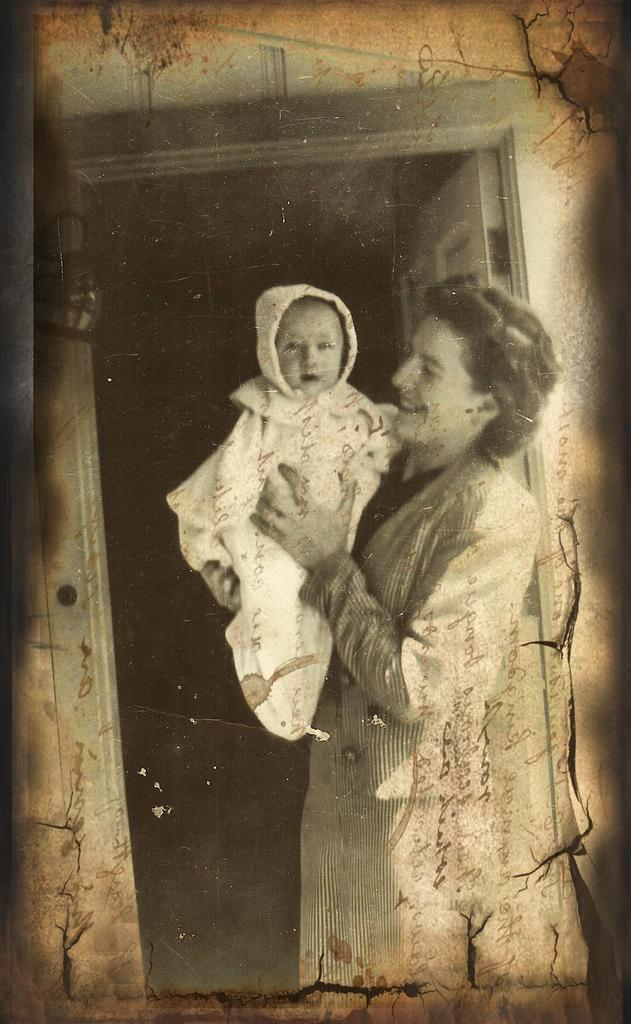What is the color scheme of the image? The image is black and white. Who is present in the image? There is a woman in the image. What is the woman holding? The woman is holding a baby. What can be seen in the background of the image? There is a wall and a door in the background of the image. What type of glass is being used to protect the baby in the image? There is no glass present in the image; the woman is simply holding the baby. 